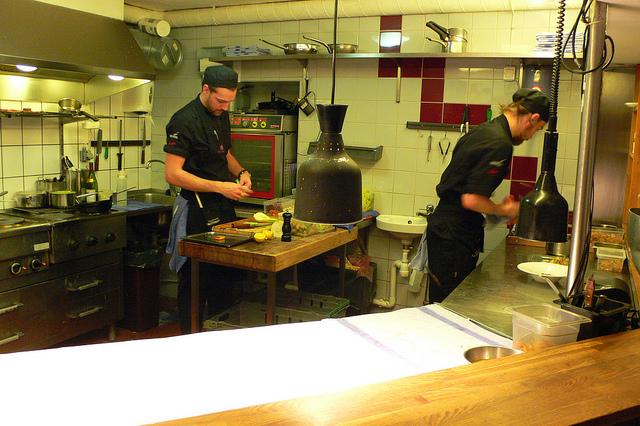Are these men cooks?
Answer briefly. Yes. What color is the accent tile in this kitchen?
Be succinct. Red. Is this a busy kitchen?
Answer briefly. No. 